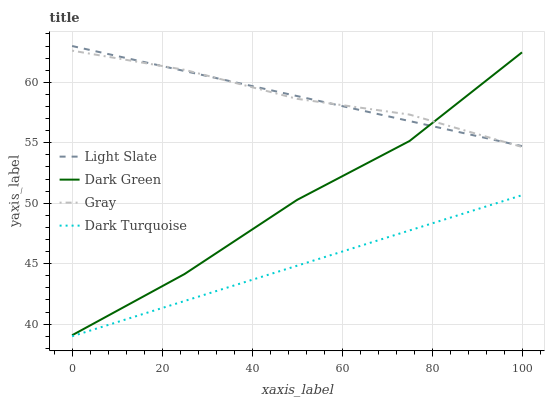Does Dark Turquoise have the minimum area under the curve?
Answer yes or no. Yes. Does Gray have the maximum area under the curve?
Answer yes or no. Yes. Does Gray have the minimum area under the curve?
Answer yes or no. No. Does Dark Turquoise have the maximum area under the curve?
Answer yes or no. No. Is Light Slate the smoothest?
Answer yes or no. Yes. Is Dark Green the roughest?
Answer yes or no. Yes. Is Gray the smoothest?
Answer yes or no. No. Is Gray the roughest?
Answer yes or no. No. Does Dark Turquoise have the lowest value?
Answer yes or no. Yes. Does Gray have the lowest value?
Answer yes or no. No. Does Light Slate have the highest value?
Answer yes or no. Yes. Does Gray have the highest value?
Answer yes or no. No. Is Dark Turquoise less than Gray?
Answer yes or no. Yes. Is Dark Green greater than Dark Turquoise?
Answer yes or no. Yes. Does Gray intersect Dark Green?
Answer yes or no. Yes. Is Gray less than Dark Green?
Answer yes or no. No. Is Gray greater than Dark Green?
Answer yes or no. No. Does Dark Turquoise intersect Gray?
Answer yes or no. No. 